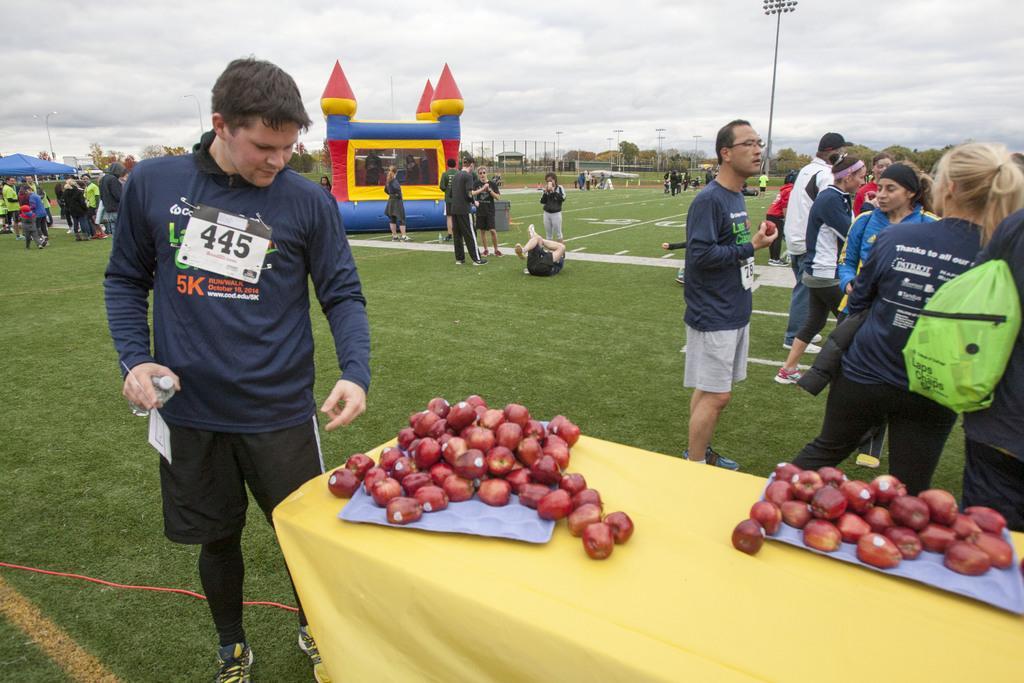Could you give a brief overview of what you see in this image? This picture is clicked outside. On the right there is a table on the top of which many number of apples are placed with the trays. On the left there is a person wearing blue color t-shirt, holding a bottle and standing on the ground. On the right corner we can see the group of people standing on the ground. In the center we can see the green grass, inflatable castle, umbrella and group of persons. In the background there is sky, trees, poles and some other objects. 